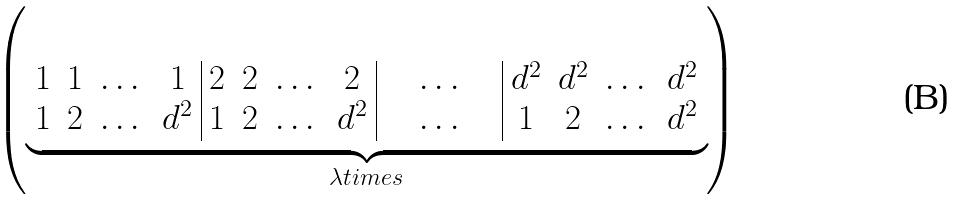Convert formula to latex. <formula><loc_0><loc_0><loc_500><loc_500>\left ( \underbrace { \begin{array} { c c c c | c c c c | c | c c c c } 1 & 1 & \dots & 1 & 2 & 2 & \dots & 2 & \quad \dots \quad & d ^ { 2 } & d ^ { 2 } & \dots & d ^ { 2 } \\ 1 & 2 & \dots & d ^ { 2 } & 1 & 2 & \dots & d ^ { 2 } & \quad \dots \quad & 1 & 2 & \dots & d ^ { 2 } \end{array} } _ { \lambda t i m e s } \right )</formula> 